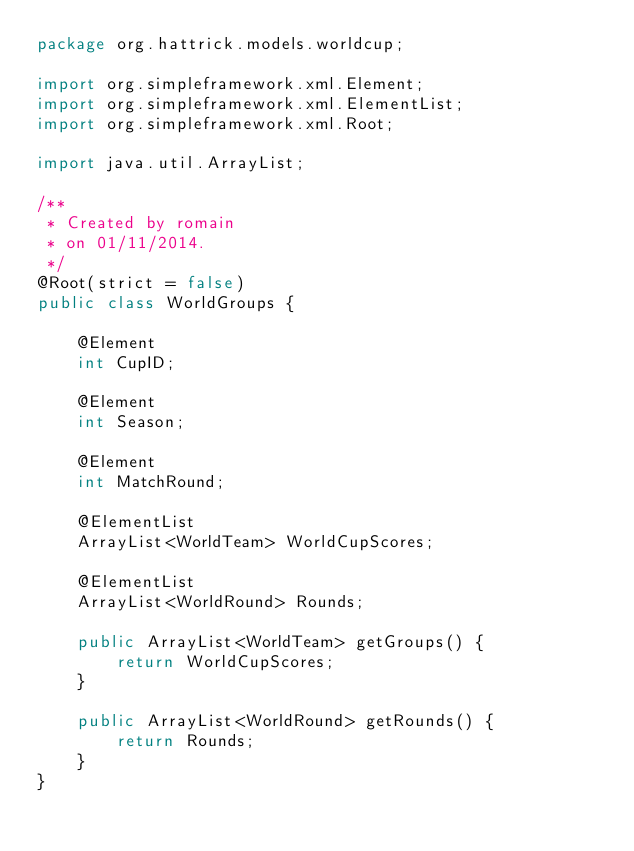Convert code to text. <code><loc_0><loc_0><loc_500><loc_500><_Java_>package org.hattrick.models.worldcup;

import org.simpleframework.xml.Element;
import org.simpleframework.xml.ElementList;
import org.simpleframework.xml.Root;

import java.util.ArrayList;

/**
 * Created by romain
 * on 01/11/2014.
 */
@Root(strict = false)
public class WorldGroups {

    @Element
    int CupID;

    @Element
    int Season;

    @Element
    int MatchRound;

    @ElementList
    ArrayList<WorldTeam> WorldCupScores;

    @ElementList
    ArrayList<WorldRound> Rounds;

    public ArrayList<WorldTeam> getGroups() {
        return WorldCupScores;
    }

    public ArrayList<WorldRound> getRounds() {
        return Rounds;
    }
}
</code> 